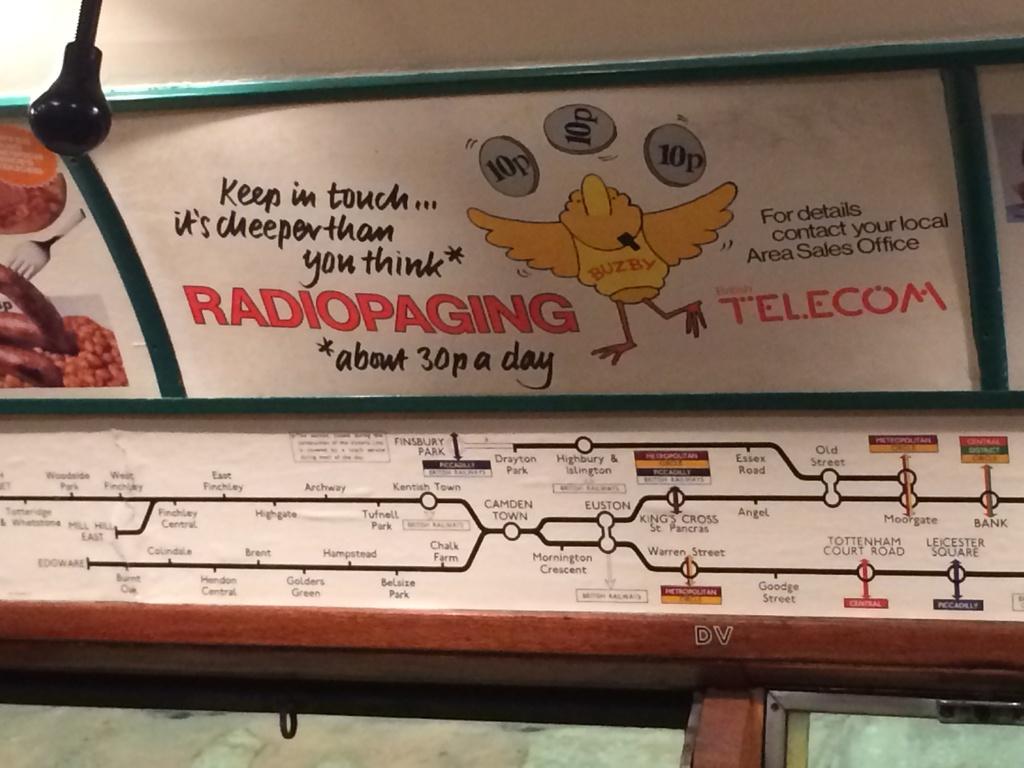Is this a diagram?
Ensure brevity in your answer.  Yes. 